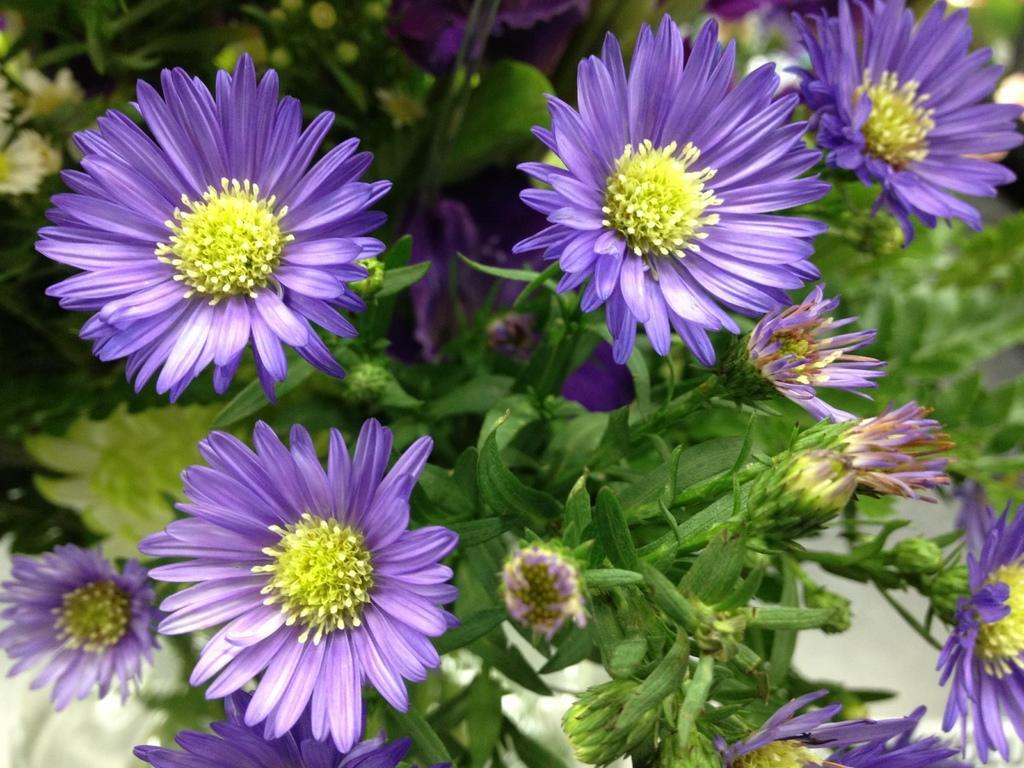Please provide a concise description of this image. In this picture there are flowers, buds and plants. The background is blurred. 